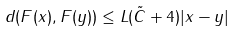Convert formula to latex. <formula><loc_0><loc_0><loc_500><loc_500>d ( F ( x ) , F ( y ) ) \leq L ( \tilde { C } + 4 ) | x - y |</formula> 